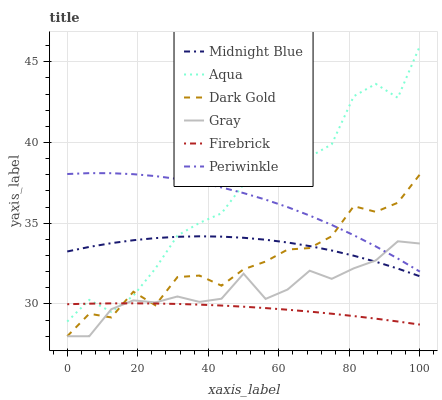Does Firebrick have the minimum area under the curve?
Answer yes or no. Yes. Does Aqua have the maximum area under the curve?
Answer yes or no. Yes. Does Midnight Blue have the minimum area under the curve?
Answer yes or no. No. Does Midnight Blue have the maximum area under the curve?
Answer yes or no. No. Is Firebrick the smoothest?
Answer yes or no. Yes. Is Aqua the roughest?
Answer yes or no. Yes. Is Midnight Blue the smoothest?
Answer yes or no. No. Is Midnight Blue the roughest?
Answer yes or no. No. Does Gray have the lowest value?
Answer yes or no. Yes. Does Midnight Blue have the lowest value?
Answer yes or no. No. Does Aqua have the highest value?
Answer yes or no. Yes. Does Midnight Blue have the highest value?
Answer yes or no. No. Is Firebrick less than Periwinkle?
Answer yes or no. Yes. Is Midnight Blue greater than Firebrick?
Answer yes or no. Yes. Does Midnight Blue intersect Dark Gold?
Answer yes or no. Yes. Is Midnight Blue less than Dark Gold?
Answer yes or no. No. Is Midnight Blue greater than Dark Gold?
Answer yes or no. No. Does Firebrick intersect Periwinkle?
Answer yes or no. No. 